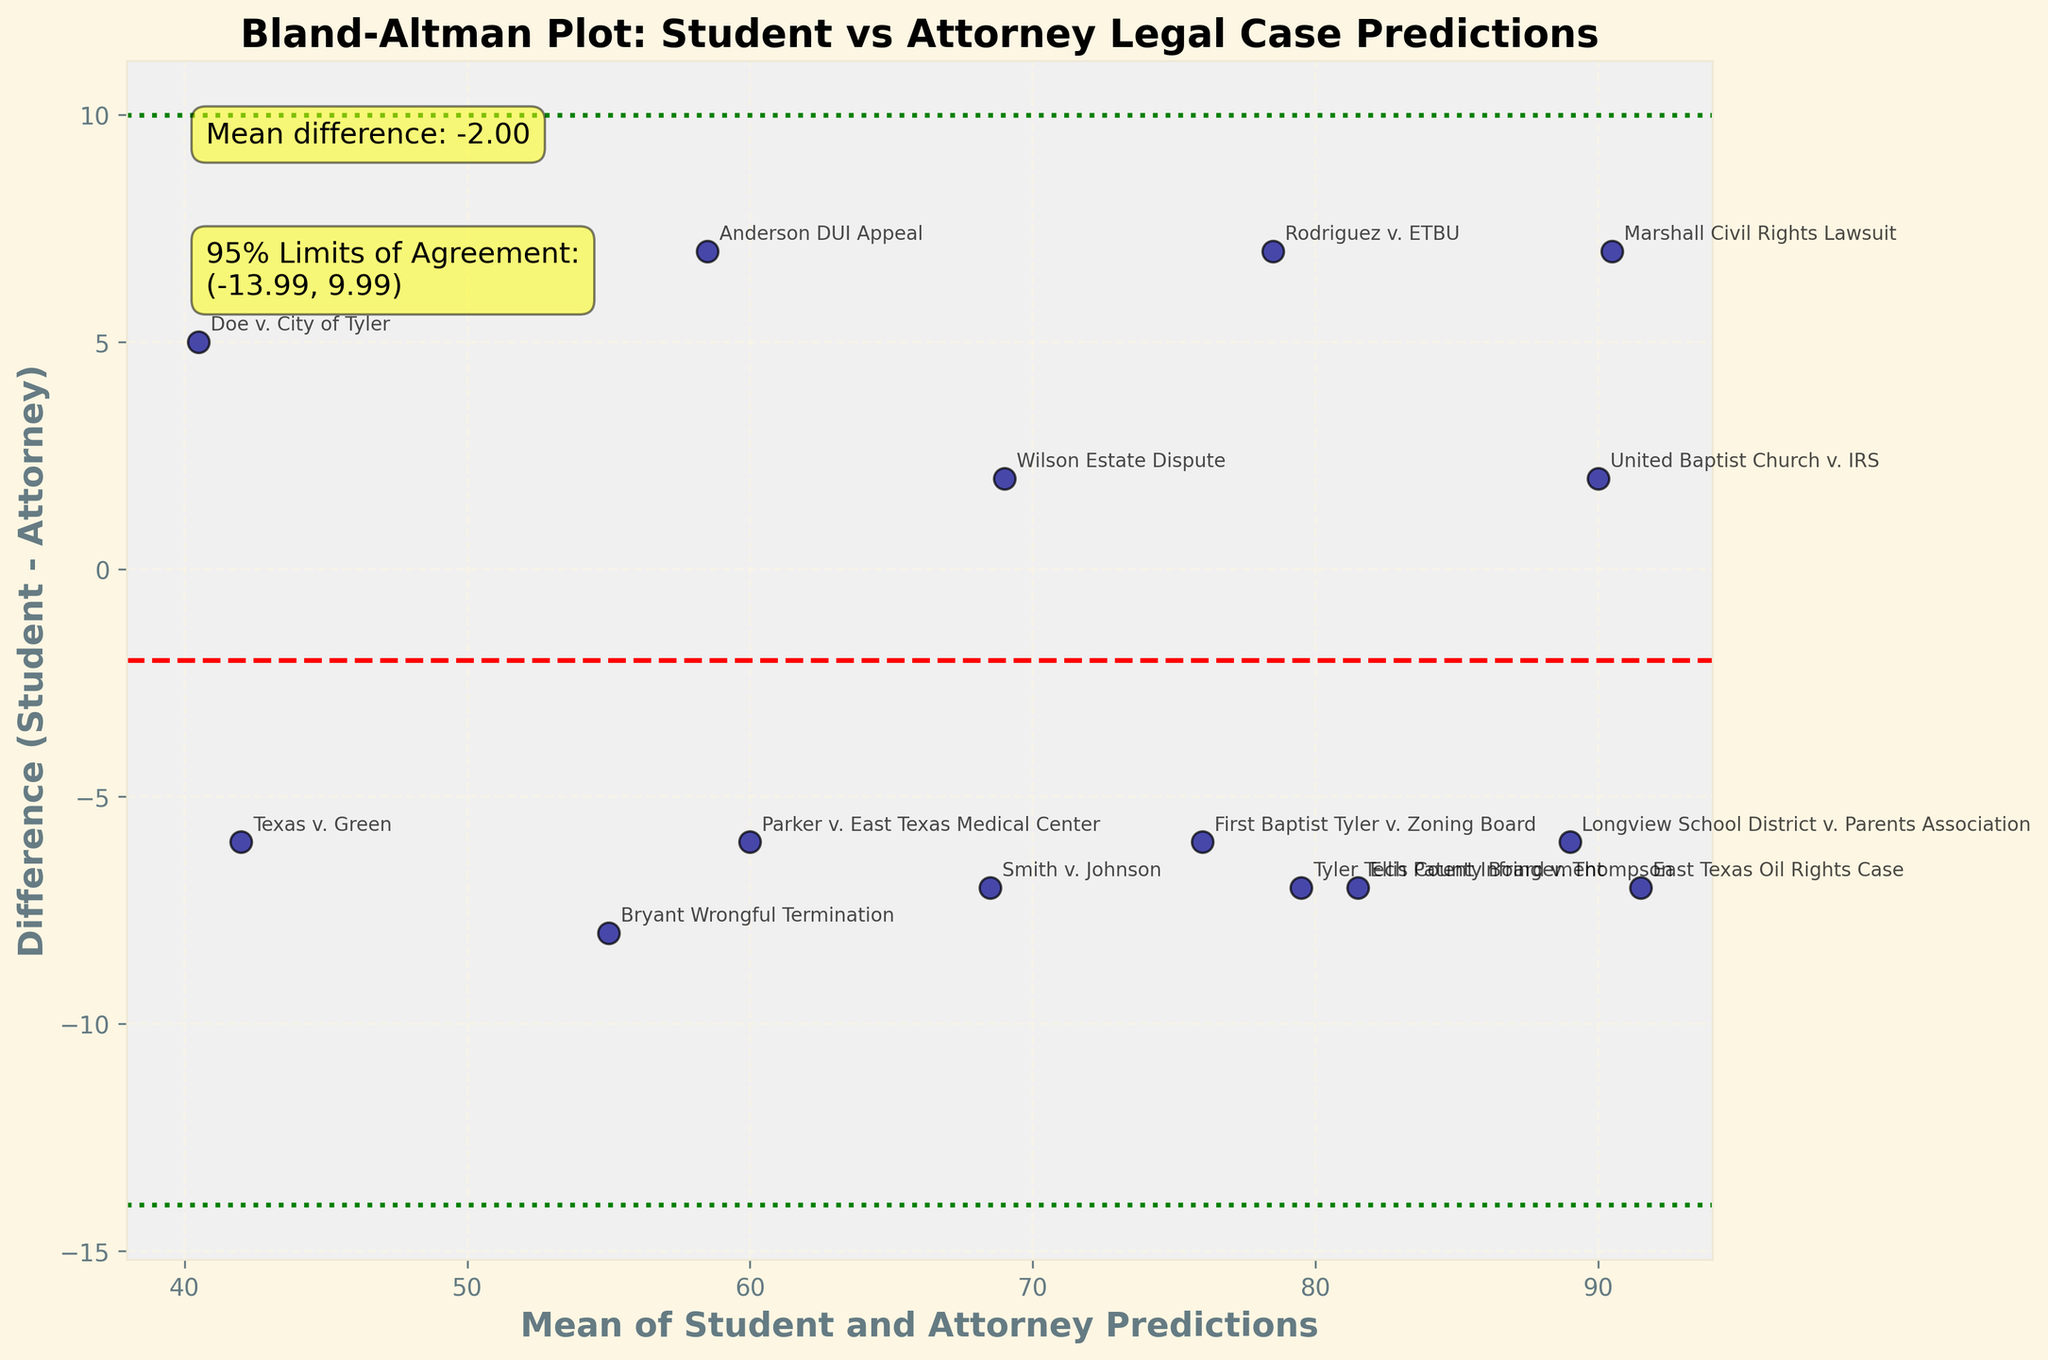What is the title of the plot? The title of the plot is "Bland-Altman Plot: Student vs Attorney Legal Case Predictions," which is present at the top of the figure and describes the main subject of the analysis.
Answer: Bland-Altman Plot: Student vs Attorney Legal Case Predictions How many data points are shown in the plot? There are 15 data points, each representing a legal case where both student and attorney predictions are provided, indicated by the number of cases listed in the dataset.
Answer: 15 What are the colors used for the scatter points and lines in the plot? The scatter points are shown in dark blue with a black edge, and the lines for mean difference and limits of agreement are in red (dashed) and green (dotted) respectively.
Answer: Dark blue with black edge (scatter points), red (mean difference), green (limits of agreement) What is the mean difference between student and attorney predictions? The mean difference is annotated on the plot and is represented by the red dashed line at mean_diff = 0.27.
Answer: 0.27 What do the green dotted lines represent? The green dotted lines are the 95% limits of agreement, indicating the range within which 95% of the differences between student and attorney predictions are expected to fall.
Answer: 95% limits of agreement Which case has the largest difference between student and attorney predictions? The case "Marshall Civil Rights Lawsuit" has the largest difference, visually identifiable as the point farthest from the red dashed line, with a difference of 7 (student: 94, attorney: 87).
Answer: Marshall Civil Rights Lawsuit What is the 95% limits of agreement range? The 95% limits of agreement range is annotated on the plot and extends from approximately -6.41 to 6.95, as indicated by the green dotted lines.
Answer: -6.41 to 6.95 Which cases fall outside the limits of agreement? Visually, the cases "Marshall Civil Rights Lawsuit" and "Anderson DUI Appeal" fall outside the green dotted lines, indicating their differences exceed the 95% limits of agreement.
Answer: Marshall Civil Rights Lawsuit, Anderson DUI Appeal What is the mean prediction value for "Doe v. City of Tyler"? For "Doe v. City of Tyler," the predictions are 43 (student) and 38 (attorney). The mean is calculated as (43 + 38) / 2 = 40.5.
Answer: 40.5 Is there a noticeable trend in the difference between predictions with increasing mean predictions? The plot does not show a noticeable trend of increasing or decreasing differences with increasing mean predictions; the differences are spread relatively evenly.
Answer: No noticeable trend 